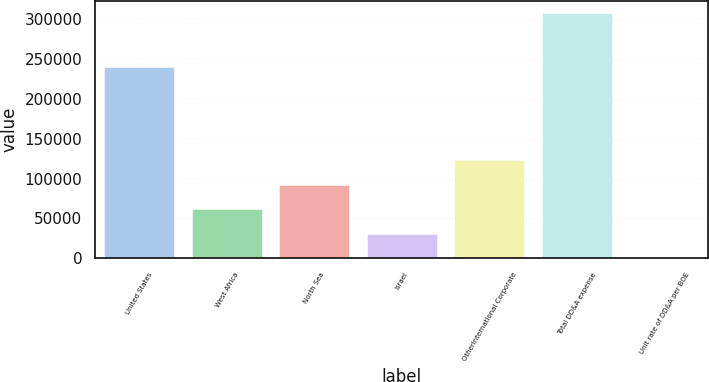Convert chart to OTSL. <chart><loc_0><loc_0><loc_500><loc_500><bar_chart><fcel>United States<fcel>West Africa<fcel>North Sea<fcel>Israel<fcel>OtherInternational Corporate<fcel>Total DD&A expense<fcel>Unit rate of DD&A per BOE<nl><fcel>240058<fcel>61627<fcel>92436.5<fcel>30817.5<fcel>123246<fcel>308103<fcel>7.97<nl></chart> 